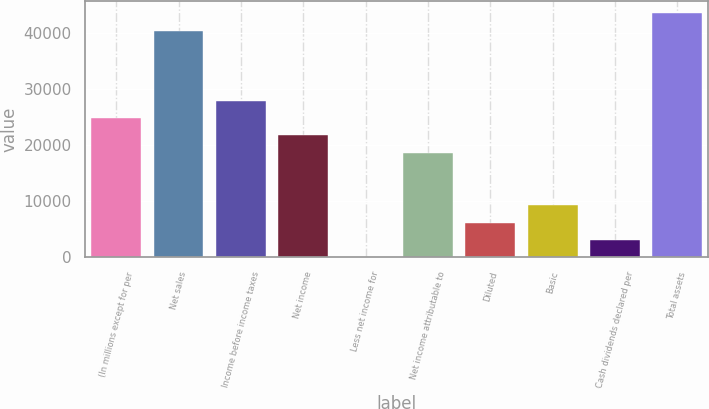Convert chart. <chart><loc_0><loc_0><loc_500><loc_500><bar_chart><fcel>(In millions except for per<fcel>Net sales<fcel>Income before income taxes<fcel>Net income<fcel>Less net income for<fcel>Net income attributable to<fcel>Diluted<fcel>Basic<fcel>Cash dividends declared per<fcel>Total assets<nl><fcel>24847.6<fcel>40376.1<fcel>27953.3<fcel>21741.9<fcel>2<fcel>18636.2<fcel>6213.4<fcel>9319.1<fcel>3107.7<fcel>43481.8<nl></chart> 